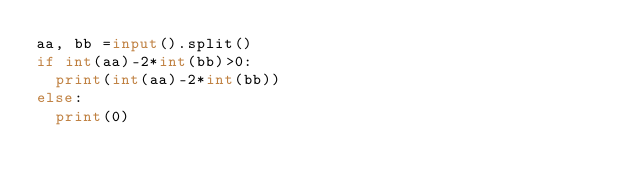<code> <loc_0><loc_0><loc_500><loc_500><_Python_>aa, bb =input().split()
if int(aa)-2*int(bb)>0:
  print(int(aa)-2*int(bb))
else:
  print(0)</code> 